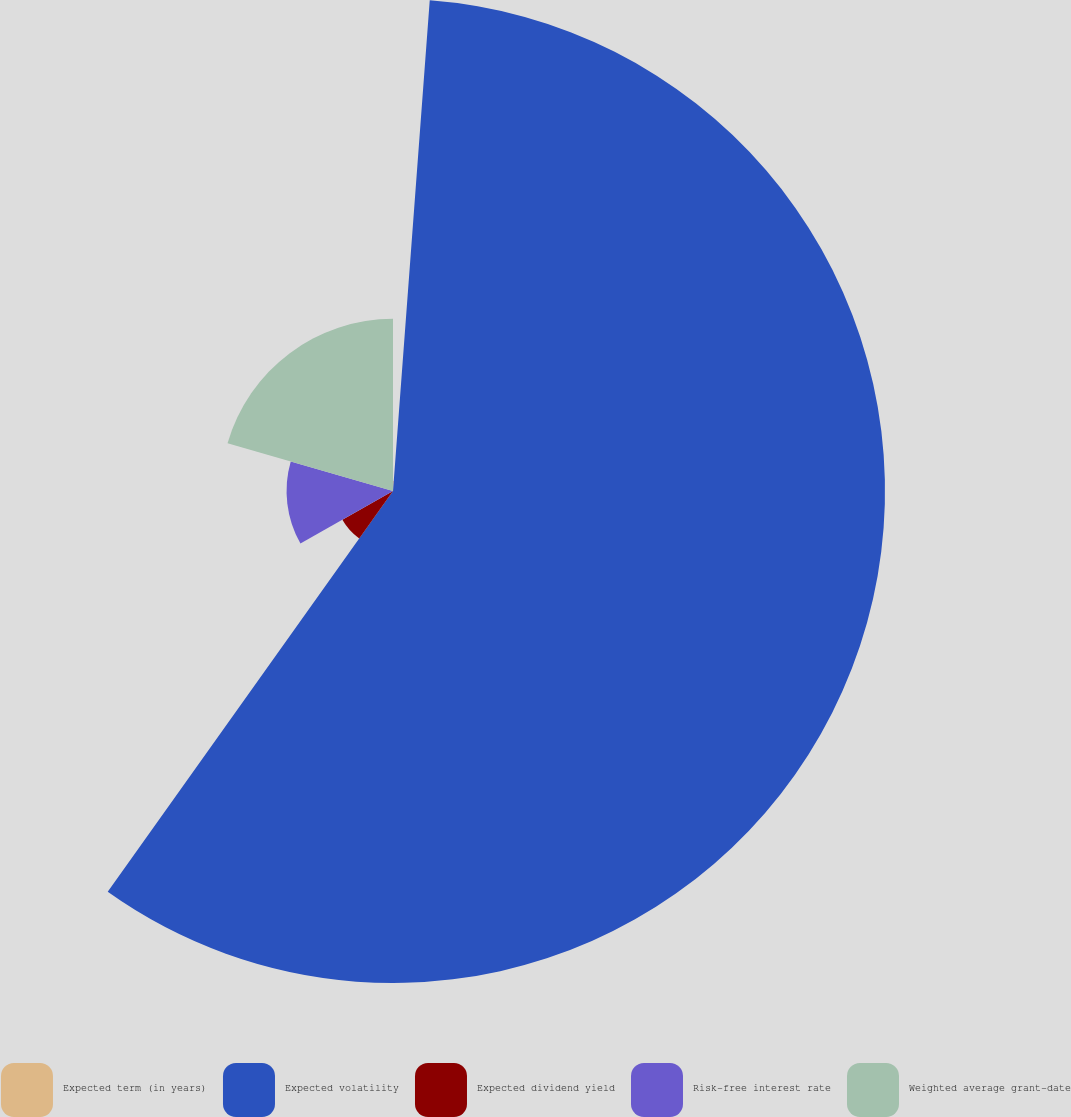<chart> <loc_0><loc_0><loc_500><loc_500><pie_chart><fcel>Expected term (in years)<fcel>Expected volatility<fcel>Expected dividend yield<fcel>Risk-free interest rate<fcel>Weighted average grant-date<nl><fcel>1.19%<fcel>58.66%<fcel>6.94%<fcel>12.69%<fcel>20.53%<nl></chart> 